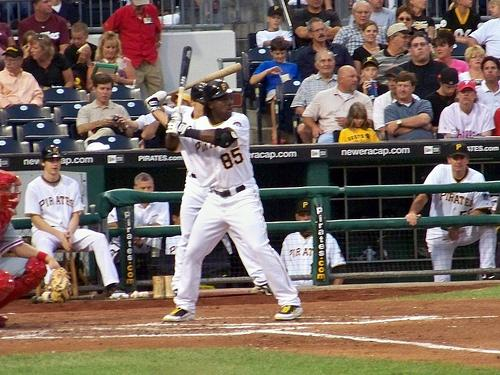What is the scene depicted in the image? A professional baseball game with players on the field, a batter up to bat, a catcher kneeling down, and fans watching the game from the bleachers. What are some objects indicating safety in the image? A black batter's safety helmet, red catcher's safety helmet, and red protective shin and knee pad for the catcher. Count the number of people wearing hats or helmets in the image. Three people are wearing hats or helmets: a person wearing a red hat, a person wearing a black batter's safety helmet, and a batter wearing a helmet. State the various colors of shirts worn by the people in the image and identify an activity one person is doing. There are persons wearing red, yellow, blue, and pink shirts. One person is drinking out of a cup. What are the additional protective gear that the baseball player at home plate is wearing? Yellow shoe laces on his black shoes. Identify the athlete in the image and describe his appearance. A professional baseball player up to bat, wearing a black safety helmet, black shoes, and a team jersey with a logo and number on it. Distinguish between the baseball players and the spectators in the image. Players: X:159 Y:40 Width:146 Height:146, spectators: X:0 Y:0 Width:499 Height:499 Extract the text from the pirates logo on the shirt. Pirates Segment the image on a semantic level, focusing on the baseball players and their equipment. Players: X:159 Y:40 Width:146 Height:146, equipment: X:97 Y:133 Width:402 Height:402 Recognize text on the baseball player's jersey regarding his number. 30 What object does "the team name on a jersey" refer to in the image? X:35 Y:191 Width:40 Height:40 Which object corresponds to "the edge of a shoe" in the image? X:269 Y:315 Width:21 Height:21 Detect any unusual elements in the image. None Determine the flavor of the ice cream the child is eating in the stands, and explain how it might affect their experience at the baseball game. No, it's not mentioned in the image. Evaluate the clarity of the image. Clear Identify the color of the shirt worn by the person drinking out of a cup. Yellow Are there any objects in the image that seem misplaced or unnatural? No Is the baseball player swinging the bat, sitting, or standing? Swinging Locate the person wearing a blue shirt. X:248 Y:36 Width:57 Height:57 Which object does not belong in a baseball game: girl sitting above the dugout, empty seat in the bleachers, or a space shuttle? Space shuttle What is the sentiment of the image? Neutral Describe the interaction between the catcher and batter. Catcher is positioned behind the batter. Count the number of basketballs in the dugout and determine if the players are playing both baseball and basketball. The image revolves around a baseball game, and there is no mention of basketballs or players participating in both sports. This instruction is intended to mislead users into searching for irrelevant details. What can you infer from the presence of fans in the image? It's a professional baseball game. What is the color of the batters safety helmet? Black Identify the position and dimensions of the head of a man in the image. X:187 Y:73 Width:91 Height:91 Assess the quality of the image in terms of focus and sharpness. Good How is the baseball player interacting with the bat? Holding the bat between his legs while sitting 